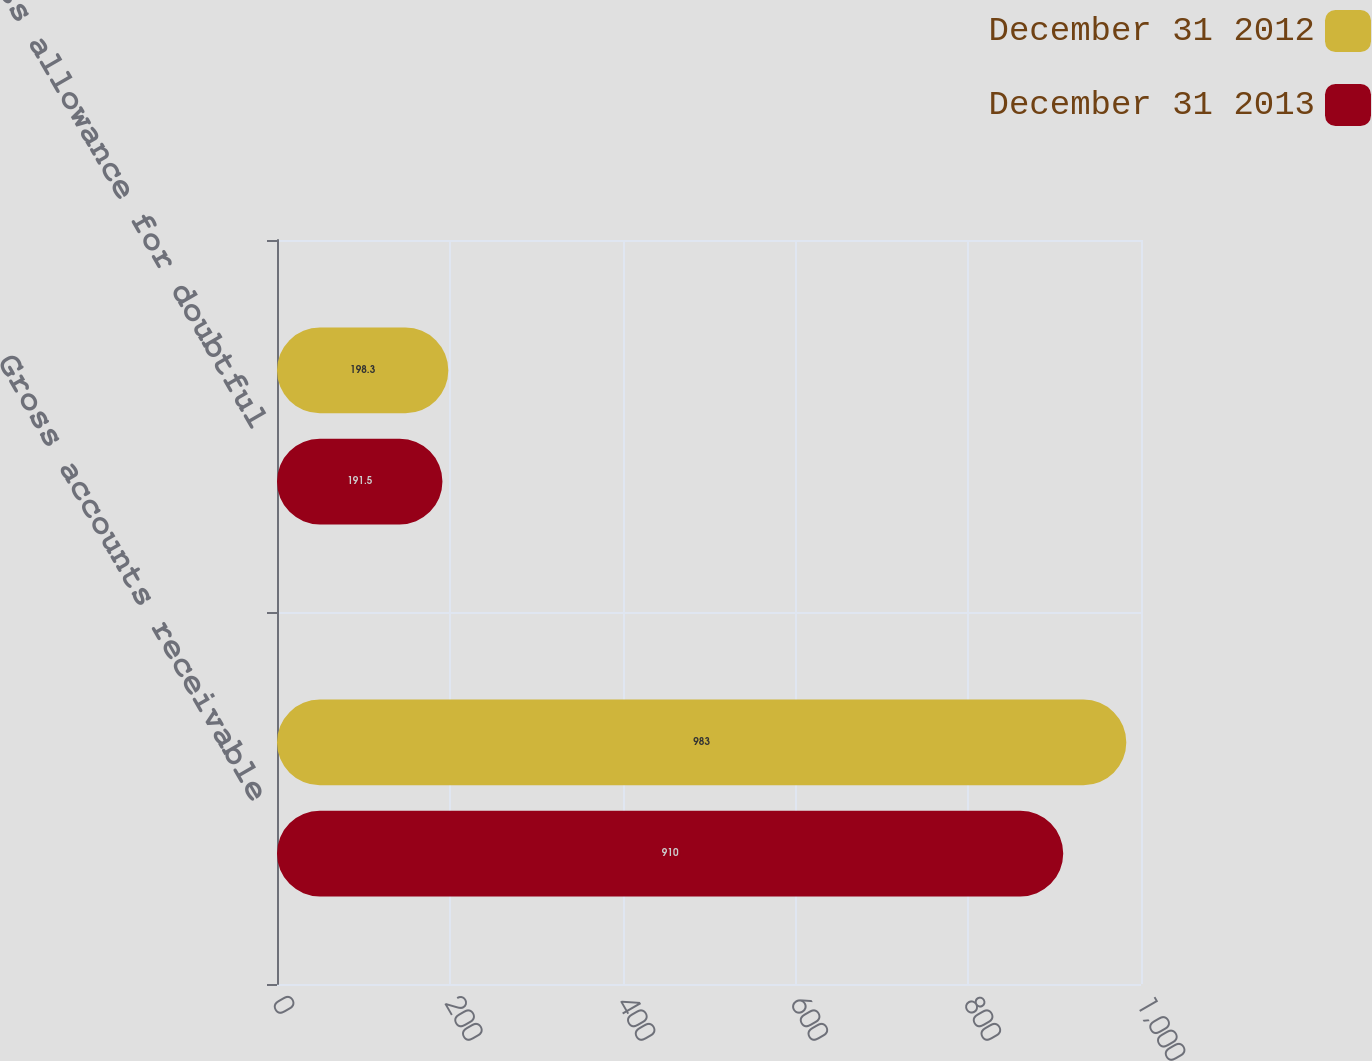<chart> <loc_0><loc_0><loc_500><loc_500><stacked_bar_chart><ecel><fcel>Gross accounts receivable<fcel>Less allowance for doubtful<nl><fcel>December 31 2012<fcel>983<fcel>198.3<nl><fcel>December 31 2013<fcel>910<fcel>191.5<nl></chart> 